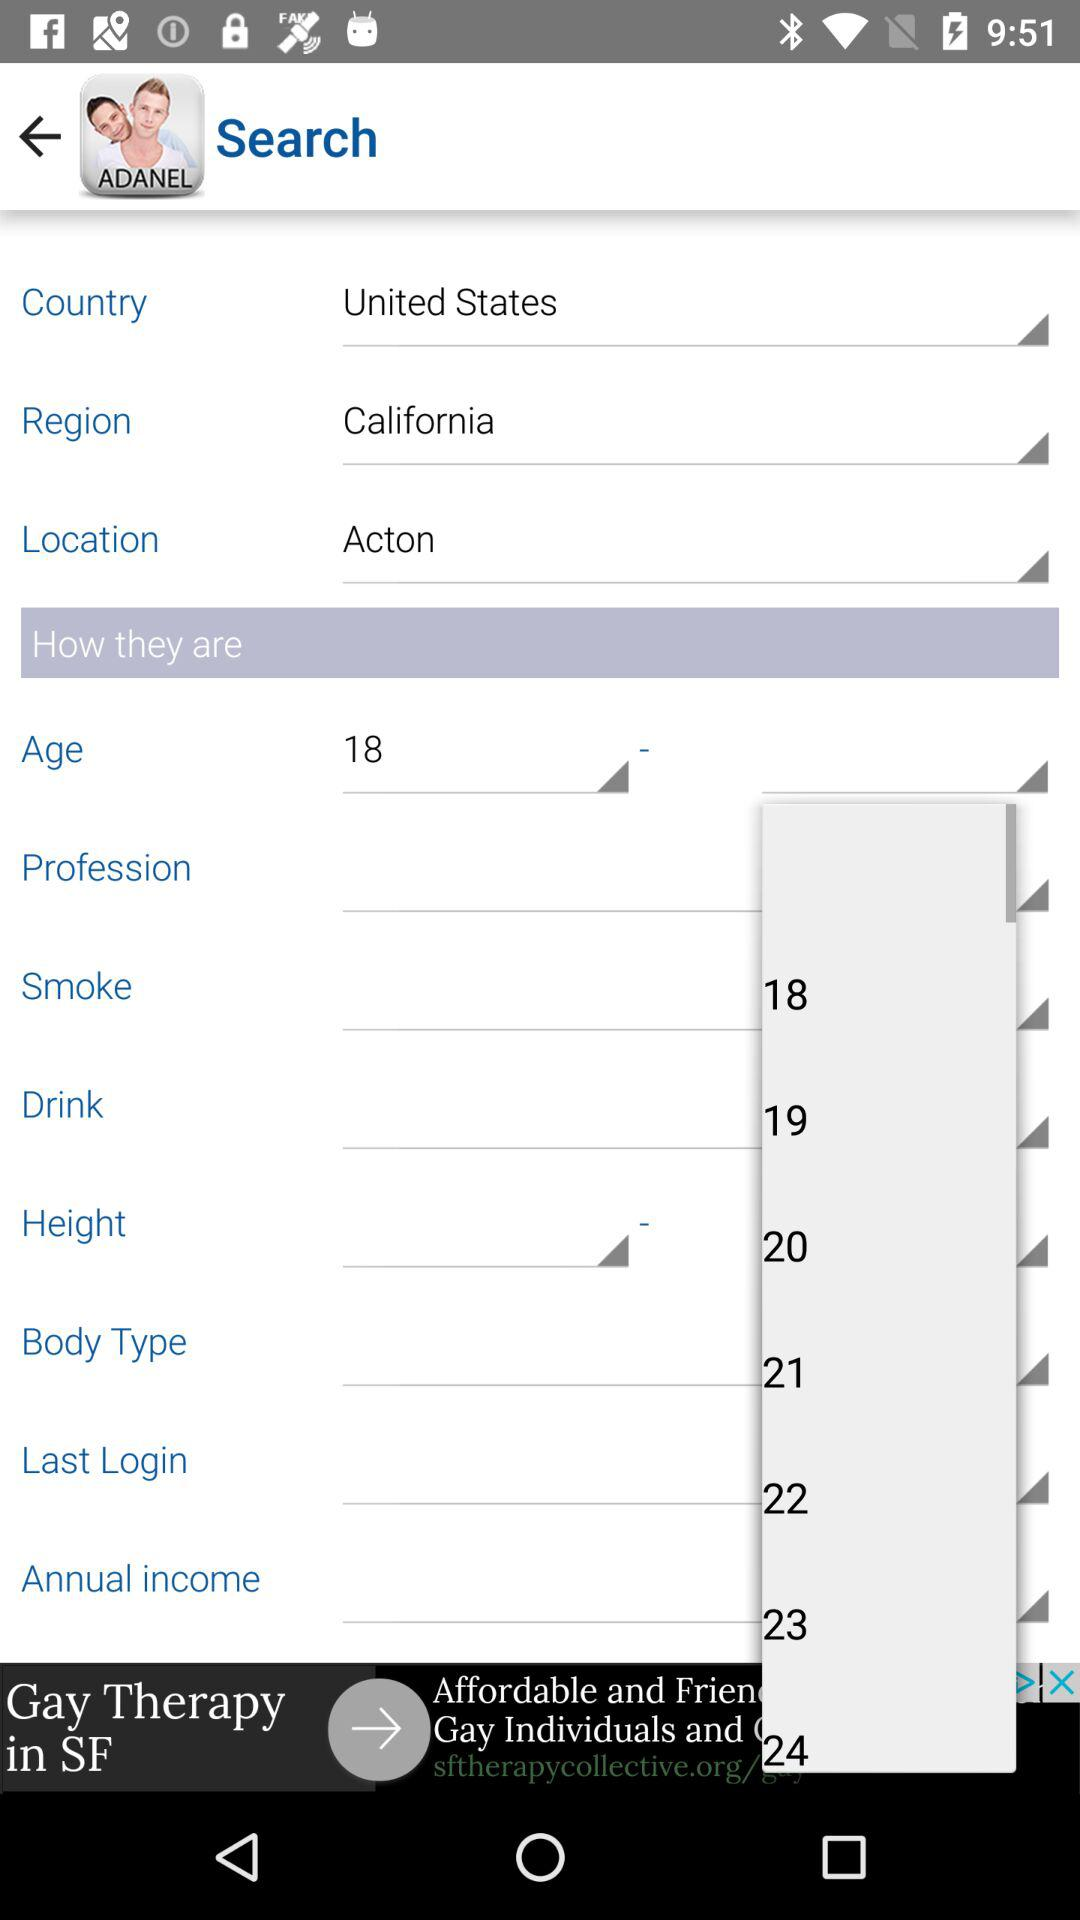What is the selected age? The selected age is 18. 